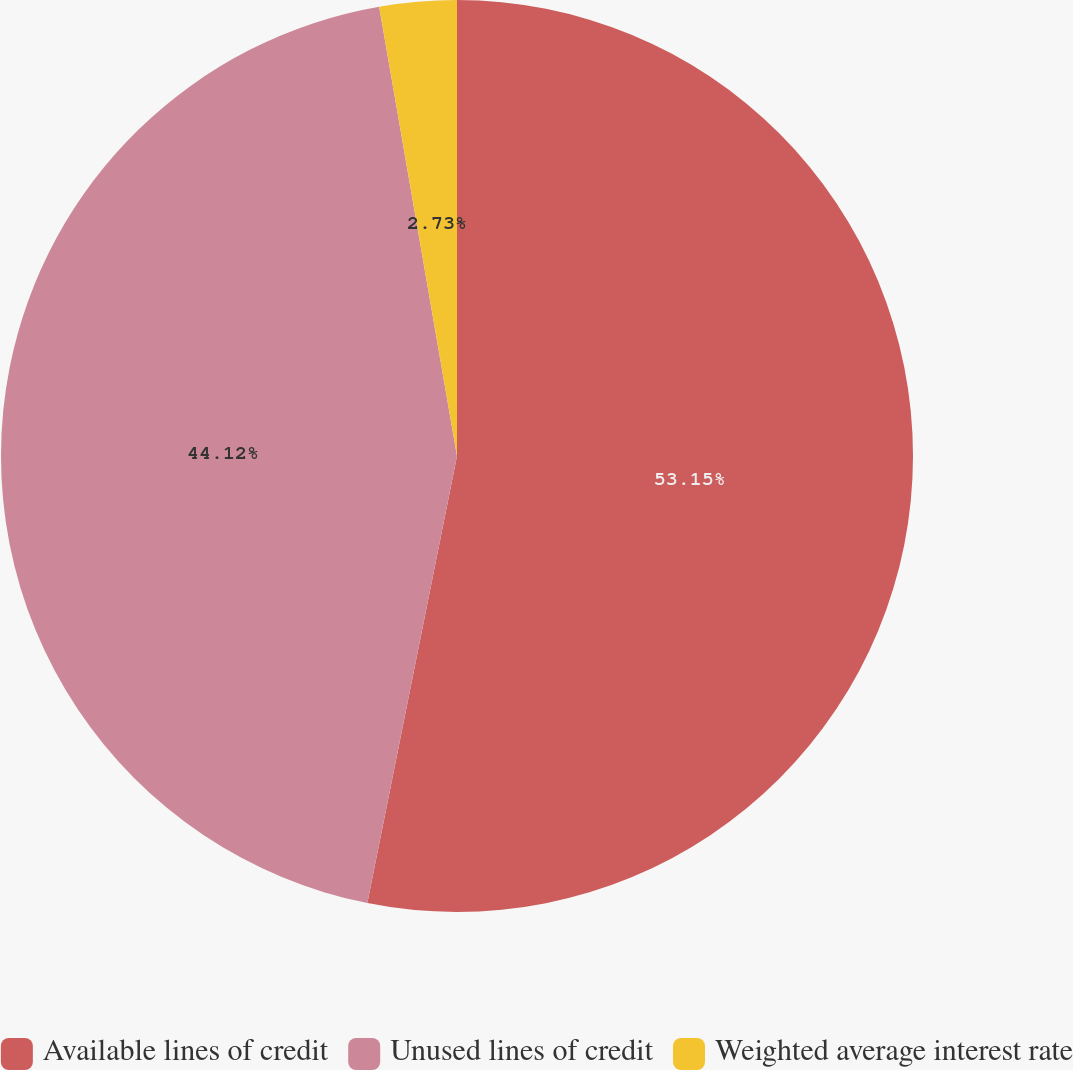<chart> <loc_0><loc_0><loc_500><loc_500><pie_chart><fcel>Available lines of credit<fcel>Unused lines of credit<fcel>Weighted average interest rate<nl><fcel>53.15%<fcel>44.12%<fcel>2.73%<nl></chart> 